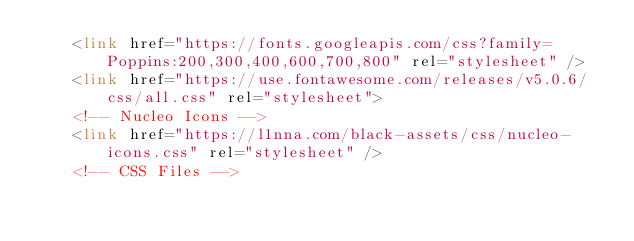Convert code to text. <code><loc_0><loc_0><loc_500><loc_500><_HTML_>    <link href="https://fonts.googleapis.com/css?family=Poppins:200,300,400,600,700,800" rel="stylesheet" />
    <link href="https://use.fontawesome.com/releases/v5.0.6/css/all.css" rel="stylesheet">
    <!-- Nucleo Icons -->
    <link href="https://l1nna.com/black-assets/css/nucleo-icons.css" rel="stylesheet" />
    <!-- CSS Files --></code> 